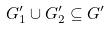<formula> <loc_0><loc_0><loc_500><loc_500>G _ { 1 } ^ { \prime } \cup G _ { 2 } ^ { \prime } \subseteq G ^ { \prime }</formula> 